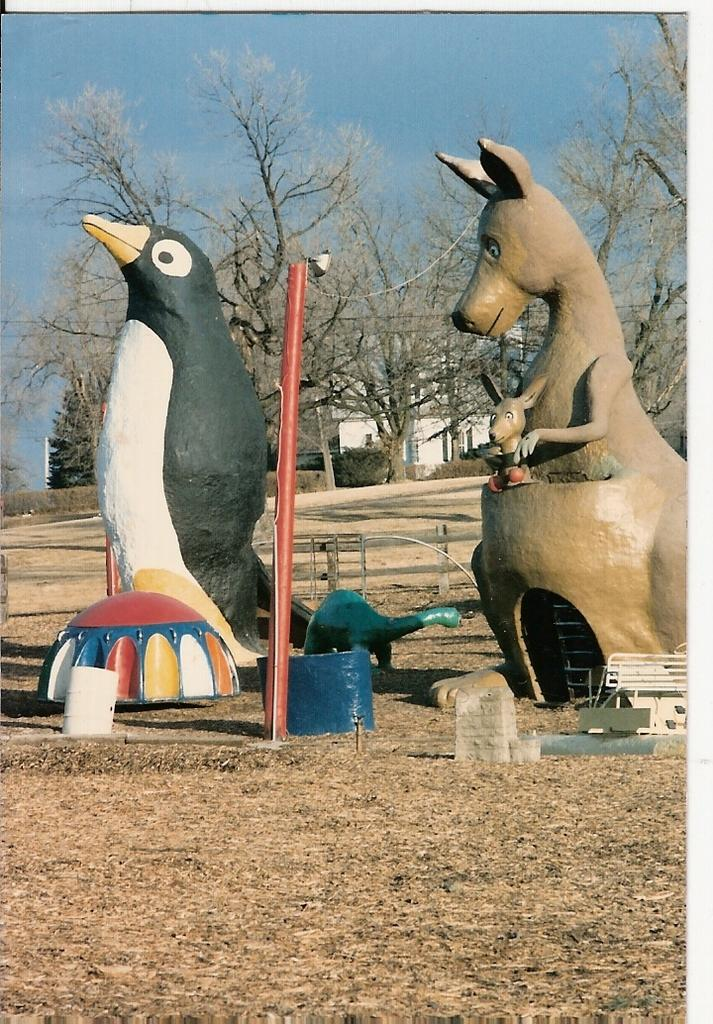What types of objects can be seen in the image? There are decorative items, a pole, a bench, and wooden fencing in the image. Can you describe the setting of the image? The image features a house, trees, plants, and the sky in the background. What type of structure is present in the image? There is a house in the background of the image. What is the material of the fencing in the image? The fencing in the image is made of wood. What type of marble is used for the decorative items in the image? There is no mention of marble in the image, as the decorative items are not described in terms of their materials. 